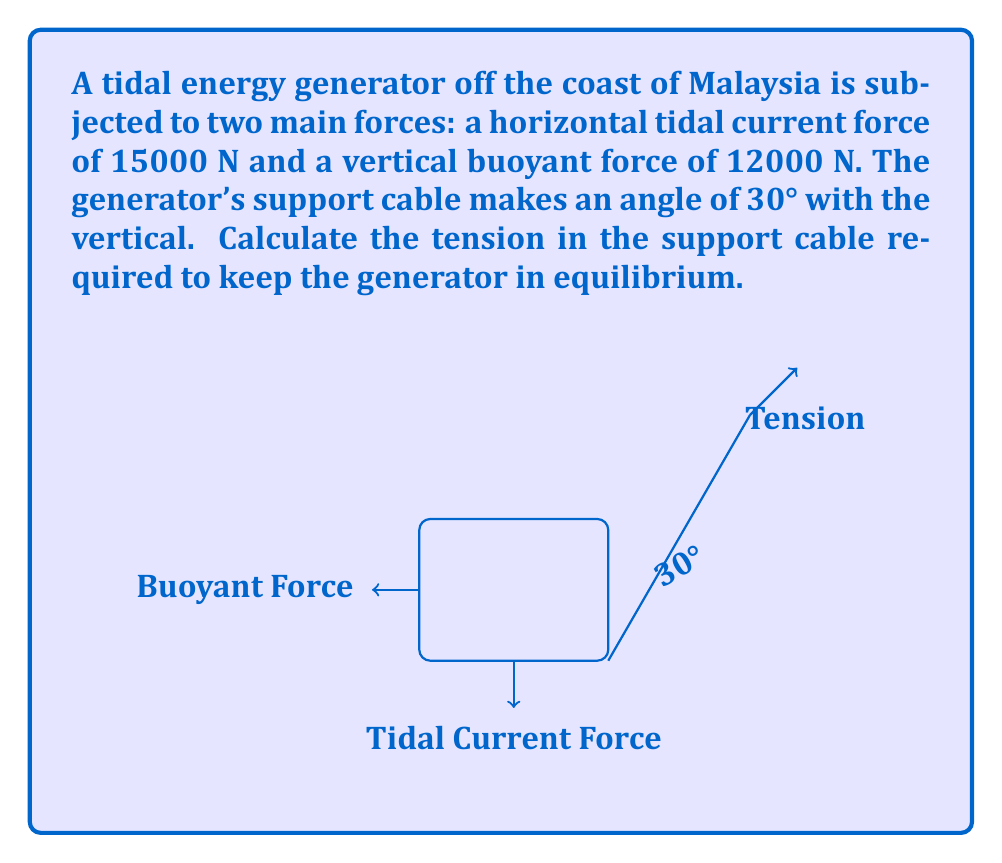Solve this math problem. Let's approach this problem step-by-step:

1) First, let's define our coordinate system. We'll use the horizontal direction as our x-axis and the vertical direction as our y-axis.

2) Now, let's break down the forces:
   - Tidal current force: $F_t = 15000$ N (horizontal, positive x-direction)
   - Buoyant force: $F_b = 12000$ N (vertical, positive y-direction)
   - Tension force: $T$ (unknown magnitude, at 30° to the vertical)

3) We can break down the tension force into its x and y components:
   - $T_x = T \sin(30°)$
   - $T_y = T \cos(30°)$

4) For the system to be in equilibrium, the sum of forces in both x and y directions must be zero:

   In x-direction: $\sum F_x = 0$
   $F_t - T_x = 0$
   $15000 - T \sin(30°) = 0$

   In y-direction: $\sum F_y = 0$
   $F_b - T_y = 0$
   $12000 - T \cos(30°) = 0$

5) We can solve either equation for T. Let's use the y-direction equation:

   $T \cos(30°) = 12000$
   $T = \frac{12000}{\cos(30°)}$

6) Using the trigonometric identity $\cos(30°) = \frac{\sqrt{3}}{2}$, we get:

   $T = \frac{12000}{\frac{\sqrt{3}}{2}} = 12000 \cdot \frac{2}{\sqrt{3}} = 8000\sqrt{3}$ N

7) We can verify this result using the x-direction equation:

   $15000 - 8000\sqrt{3} \sin(30°) = 15000 - 8000\sqrt{3} \cdot \frac{1}{2} = 15000 - 4000\sqrt{3} = 0$

Thus, the tension in the support cable is $8000\sqrt{3}$ N.
Answer: $8000\sqrt{3}$ N 